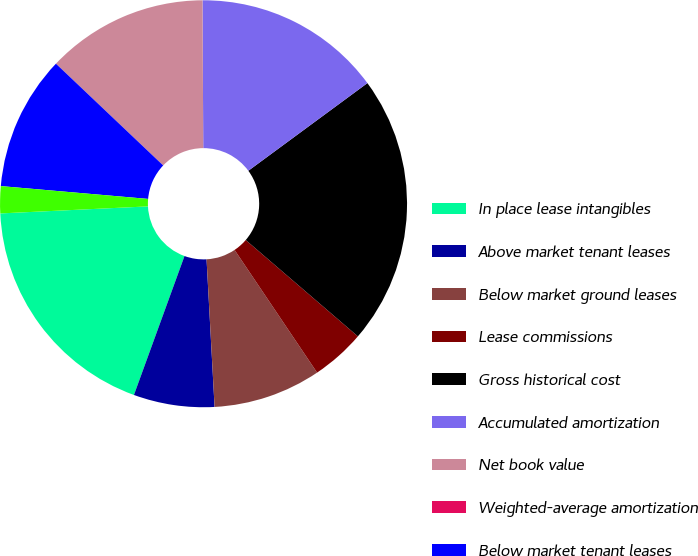Convert chart. <chart><loc_0><loc_0><loc_500><loc_500><pie_chart><fcel>In place lease intangibles<fcel>Above market tenant leases<fcel>Below market ground leases<fcel>Lease commissions<fcel>Gross historical cost<fcel>Accumulated amortization<fcel>Net book value<fcel>Weighted-average amortization<fcel>Below market tenant leases<fcel>Above market ground leases<nl><fcel>18.69%<fcel>6.42%<fcel>8.56%<fcel>4.28%<fcel>21.4%<fcel>14.98%<fcel>12.84%<fcel>0.0%<fcel>10.7%<fcel>2.14%<nl></chart> 